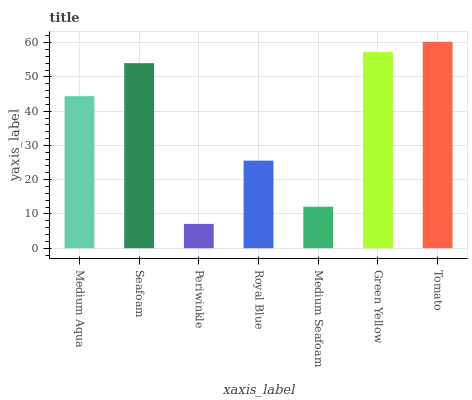Is Periwinkle the minimum?
Answer yes or no. Yes. Is Tomato the maximum?
Answer yes or no. Yes. Is Seafoam the minimum?
Answer yes or no. No. Is Seafoam the maximum?
Answer yes or no. No. Is Seafoam greater than Medium Aqua?
Answer yes or no. Yes. Is Medium Aqua less than Seafoam?
Answer yes or no. Yes. Is Medium Aqua greater than Seafoam?
Answer yes or no. No. Is Seafoam less than Medium Aqua?
Answer yes or no. No. Is Medium Aqua the high median?
Answer yes or no. Yes. Is Medium Aqua the low median?
Answer yes or no. Yes. Is Tomato the high median?
Answer yes or no. No. Is Periwinkle the low median?
Answer yes or no. No. 